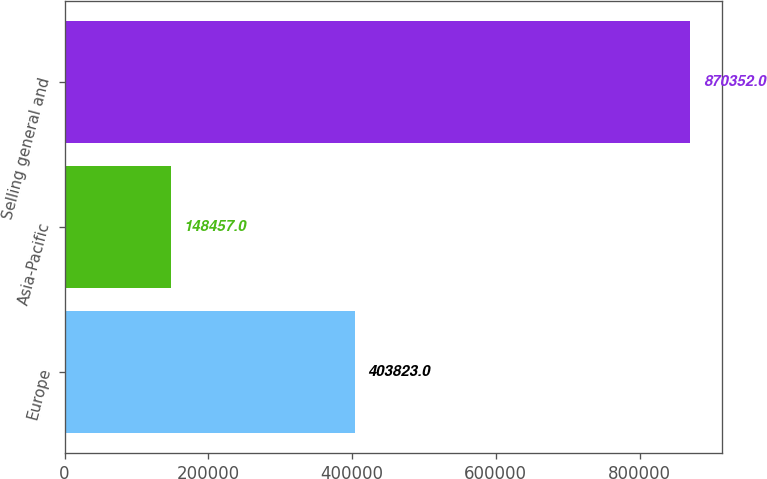Convert chart. <chart><loc_0><loc_0><loc_500><loc_500><bar_chart><fcel>Europe<fcel>Asia-Pacific<fcel>Selling general and<nl><fcel>403823<fcel>148457<fcel>870352<nl></chart> 